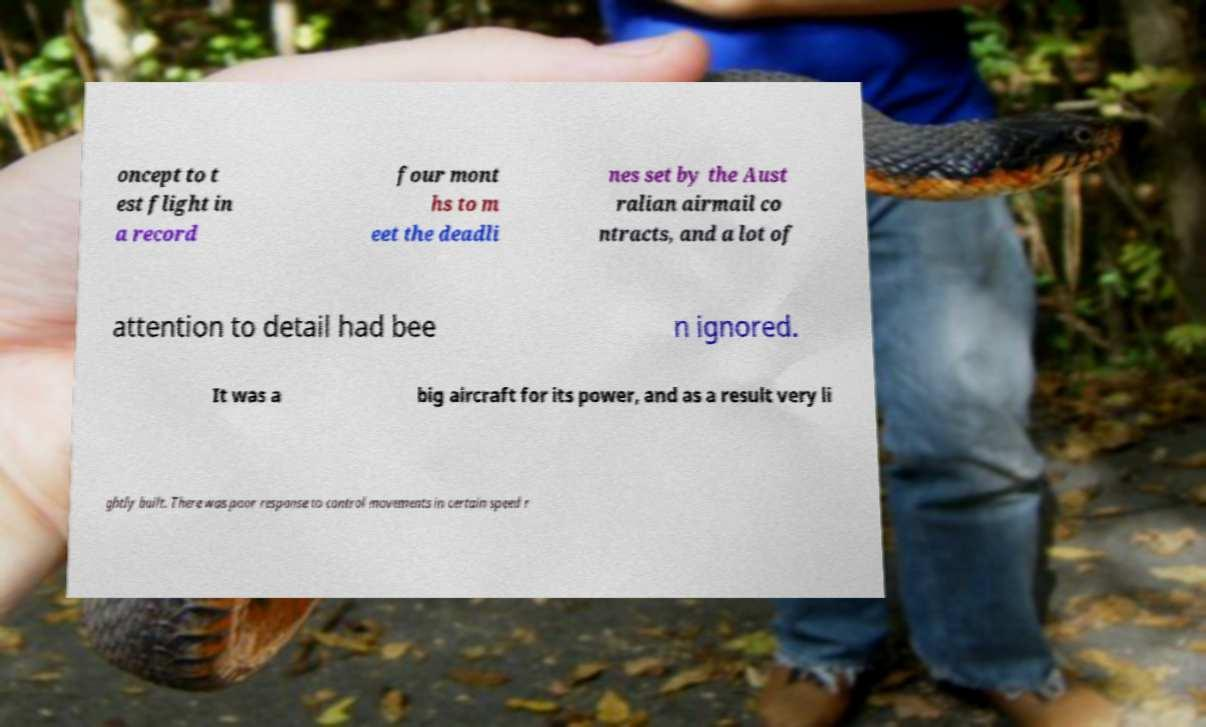Can you read and provide the text displayed in the image?This photo seems to have some interesting text. Can you extract and type it out for me? oncept to t est flight in a record four mont hs to m eet the deadli nes set by the Aust ralian airmail co ntracts, and a lot of attention to detail had bee n ignored. It was a big aircraft for its power, and as a result very li ghtly built. There was poor response to control movements in certain speed r 